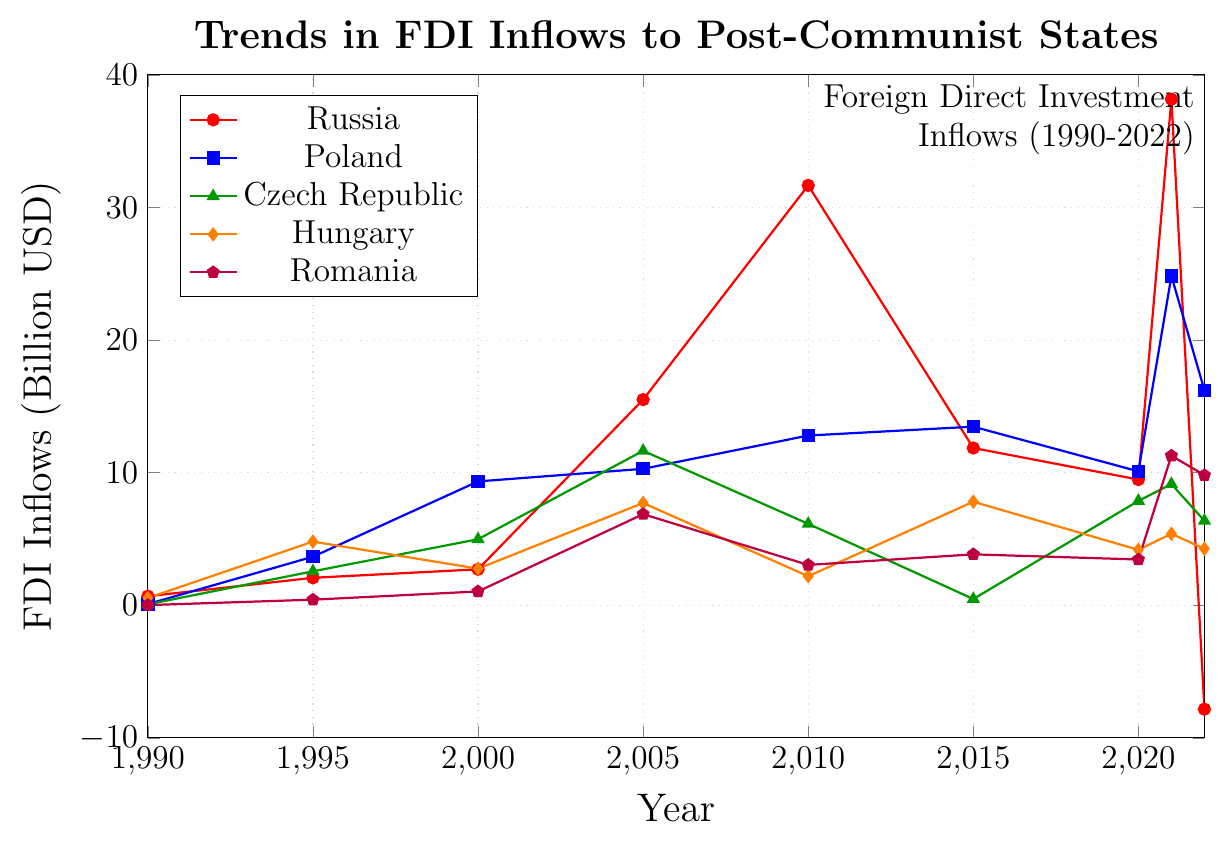Which year did Russia experience the highest FDI inflows? The highest point on the Russia line is in the year 2021, reaching approximately 38.17 billion USD.
Answer: 2021 How do the FDI inflows to Poland in 2022 compare to those in the Czech Republic in the same year? In 2022, Poland's FDI inflows are at 16.21 billion USD, while the Czech Republic's are at 6.37 billion USD. Poland's inflows are higher.
Answer: Poland's inflows are higher Between which years did Hungary see a significant drop in FDI inflows? Hungary's FDI dropped significantly from 4.80 billion USD in 1995 to 2.76 billion USD in 2000.
Answer: Between 1995 and 2000 What is the average FDI inflow to Romania from 2005 to 2022? FDI inflows for Romania from 2005 to 2022 are 6.87, 3.04, 3.84, 3.45, 11.28, and 9.81. The sum is 38.29, and dividing by 6 gives approximately 6.38 billion USD.
Answer: 6.38 billion USD Which country saw a negative FDI inflow in 2022? The value for Russia in 2022 is -7.84, which is negative.
Answer: Russia How did the FDI inflows to the Czech Republic change from 2015 to 2020? The FDI inflows to the Czech Republic increased from 0.47 billion USD in 2015 to 7.87 billion USD in 2020.
Answer: Increased Comparing the FDI inflows to Hungary and Romania in 2021, which country received more? In 2021, Hungary's FDI inflows were 5.39 billion USD, while Romania's were 11.28 billion USD. Romania received more.
Answer: Romania Identify the trends in FDI inflows for Poland from 1990 to 2022. Poland's FDI inflows trend upwards from 0.09 billion USD in 1990 to peak at 24.84 billion USD in 2021, with fluctuations.
Answer: Increasing trend with fluctuations What are the combined FDI inflows for all countries in 2005? Adding the values for all countries in 2005: Russia (15.51), Poland (10.29), Czech Republic (11.65), Hungary (7.71), Romania (6.87) equals 52.03 billion USD.
Answer: 52.03 billion USD How did the FDI inflows to Russia change between 2000 and 2005? Russia's FDI inflows rose from 2.71 billion USD in 2000 to 15.51 billion USD in 2005.
Answer: Increased 